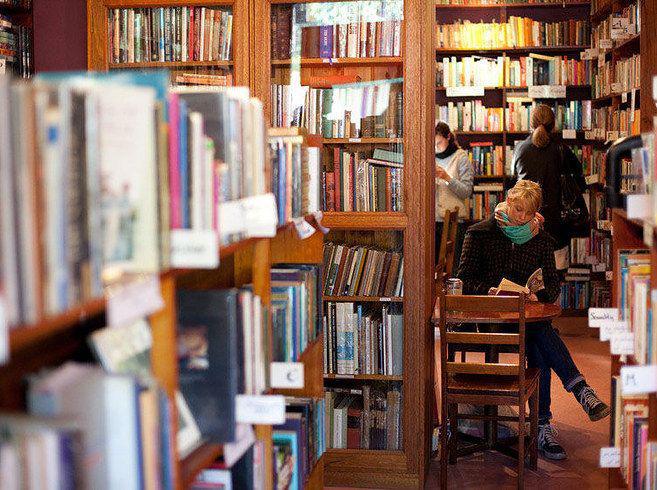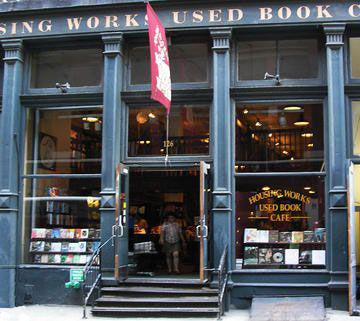The first image is the image on the left, the second image is the image on the right. For the images displayed, is the sentence "There are people sitting." factually correct? Answer yes or no. Yes. The first image is the image on the left, the second image is the image on the right. For the images displayed, is the sentence "Each image is of the sidewalk exterior of a bookstore, one with the front door standing open and one with the front door closed." factually correct? Answer yes or no. No. 